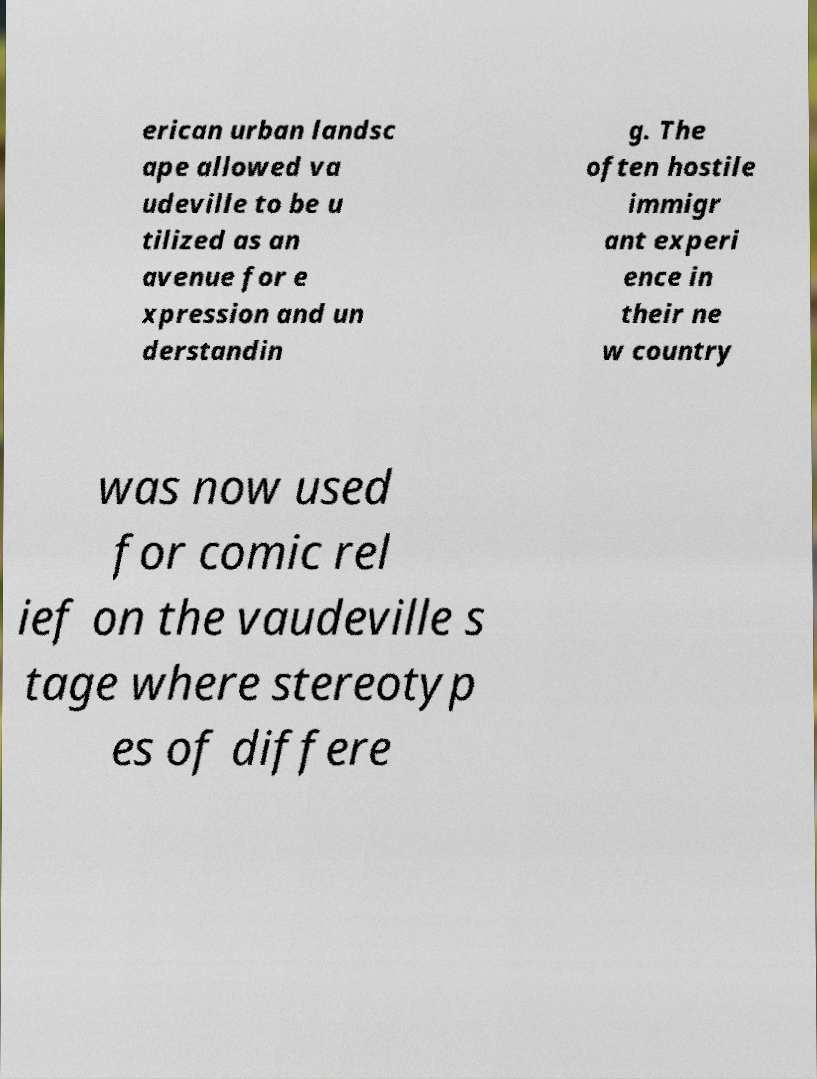Could you assist in decoding the text presented in this image and type it out clearly? erican urban landsc ape allowed va udeville to be u tilized as an avenue for e xpression and un derstandin g. The often hostile immigr ant experi ence in their ne w country was now used for comic rel ief on the vaudeville s tage where stereotyp es of differe 